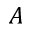<formula> <loc_0><loc_0><loc_500><loc_500>A</formula> 